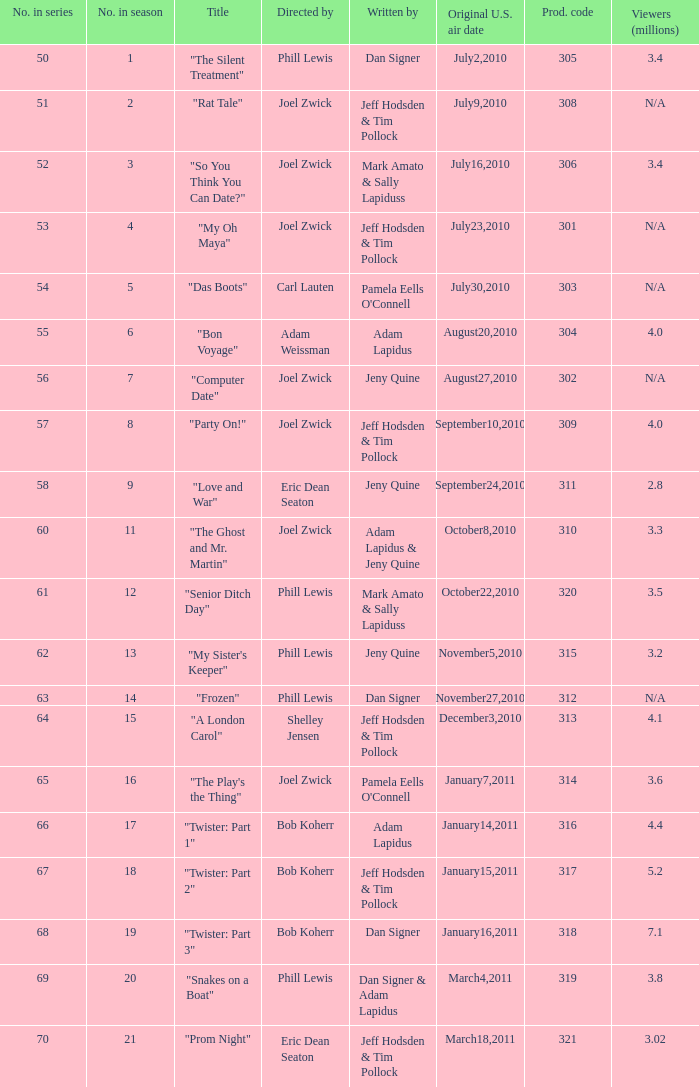On which us airing date were there January14,2011. 